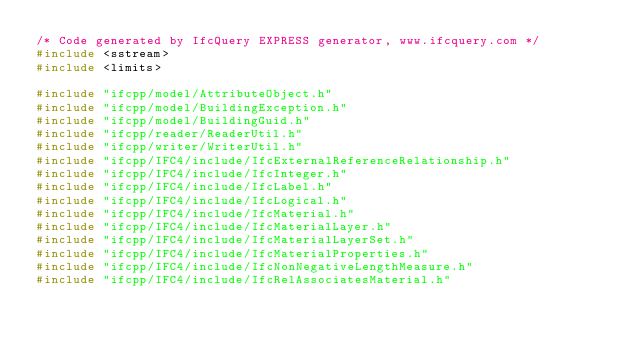Convert code to text. <code><loc_0><loc_0><loc_500><loc_500><_C++_>/* Code generated by IfcQuery EXPRESS generator, www.ifcquery.com */
#include <sstream>
#include <limits>

#include "ifcpp/model/AttributeObject.h"
#include "ifcpp/model/BuildingException.h"
#include "ifcpp/model/BuildingGuid.h"
#include "ifcpp/reader/ReaderUtil.h"
#include "ifcpp/writer/WriterUtil.h"
#include "ifcpp/IFC4/include/IfcExternalReferenceRelationship.h"
#include "ifcpp/IFC4/include/IfcInteger.h"
#include "ifcpp/IFC4/include/IfcLabel.h"
#include "ifcpp/IFC4/include/IfcLogical.h"
#include "ifcpp/IFC4/include/IfcMaterial.h"
#include "ifcpp/IFC4/include/IfcMaterialLayer.h"
#include "ifcpp/IFC4/include/IfcMaterialLayerSet.h"
#include "ifcpp/IFC4/include/IfcMaterialProperties.h"
#include "ifcpp/IFC4/include/IfcNonNegativeLengthMeasure.h"
#include "ifcpp/IFC4/include/IfcRelAssociatesMaterial.h"</code> 